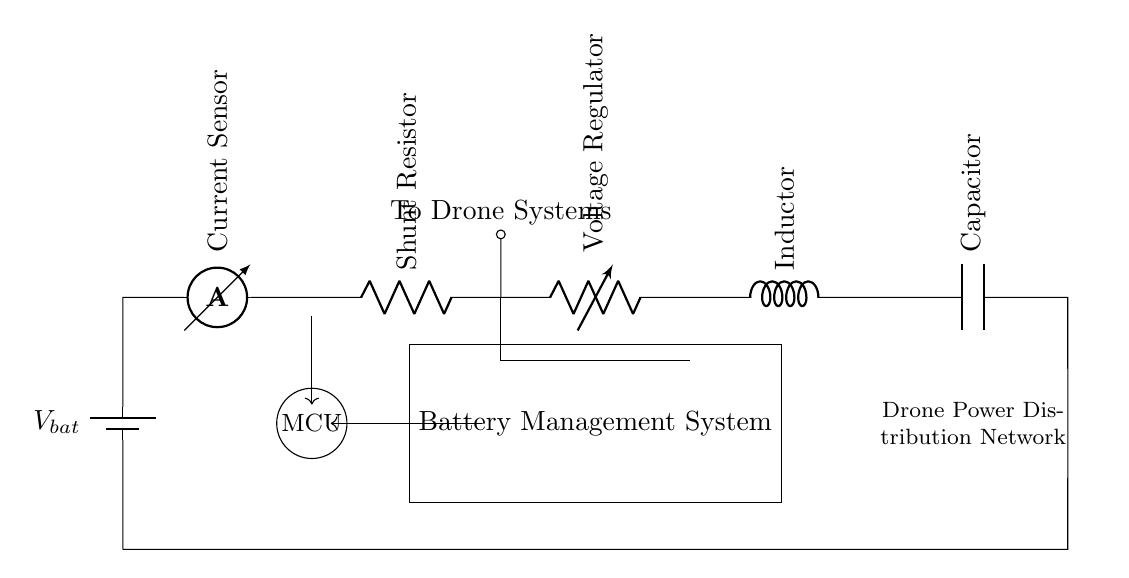What is the component labeled as V_bat? V_bat is the battery component providing the power supply to the circuit. It is the starting point of the circuit, indicated at the top left.
Answer: battery What is the purpose of the shunt resistor in this circuit? The shunt resistor's purpose is to measure the current flowing through the circuit by creating a small voltage drop, allowing for current sensing without affecting the overall circuit operation.
Answer: current sensing How many components are connected in series from the battery to the load? Analyzing the circuit diagram, there are six main components connected in series: battery, current sensor, shunt resistor, voltage regulator, inductor, and capacitor.
Answer: six Which component regulates output voltage for the drone systems? The voltage regulator in the circuit is responsible for regulating and providing a stable output voltage to the downstream systems.
Answer: voltage regulator What type of circuit is illustrated in the diagram? The illustrated circuit is a series circuit, as all components are connected end-to-end and share the same current path.
Answer: series circuit What is connected at the output of the circuit's voltage regulator? The output of the voltage regulator connects to the drone systems, which indicates that the regulated voltage is supplied directly to them for operation.
Answer: to drone systems What is the function of the capacitor in this circuit? The capacitor's function is to store electrical energy and smooth out voltage fluctuations in the circuit, improving power quality for the drone's systems.
Answer: energy storage 